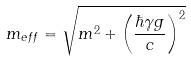<formula> <loc_0><loc_0><loc_500><loc_500>m _ { e f f } = \sqrt { m ^ { 2 } + \left ( \frac { \hbar { \gamma } g } { c } \right ) ^ { 2 } }</formula> 